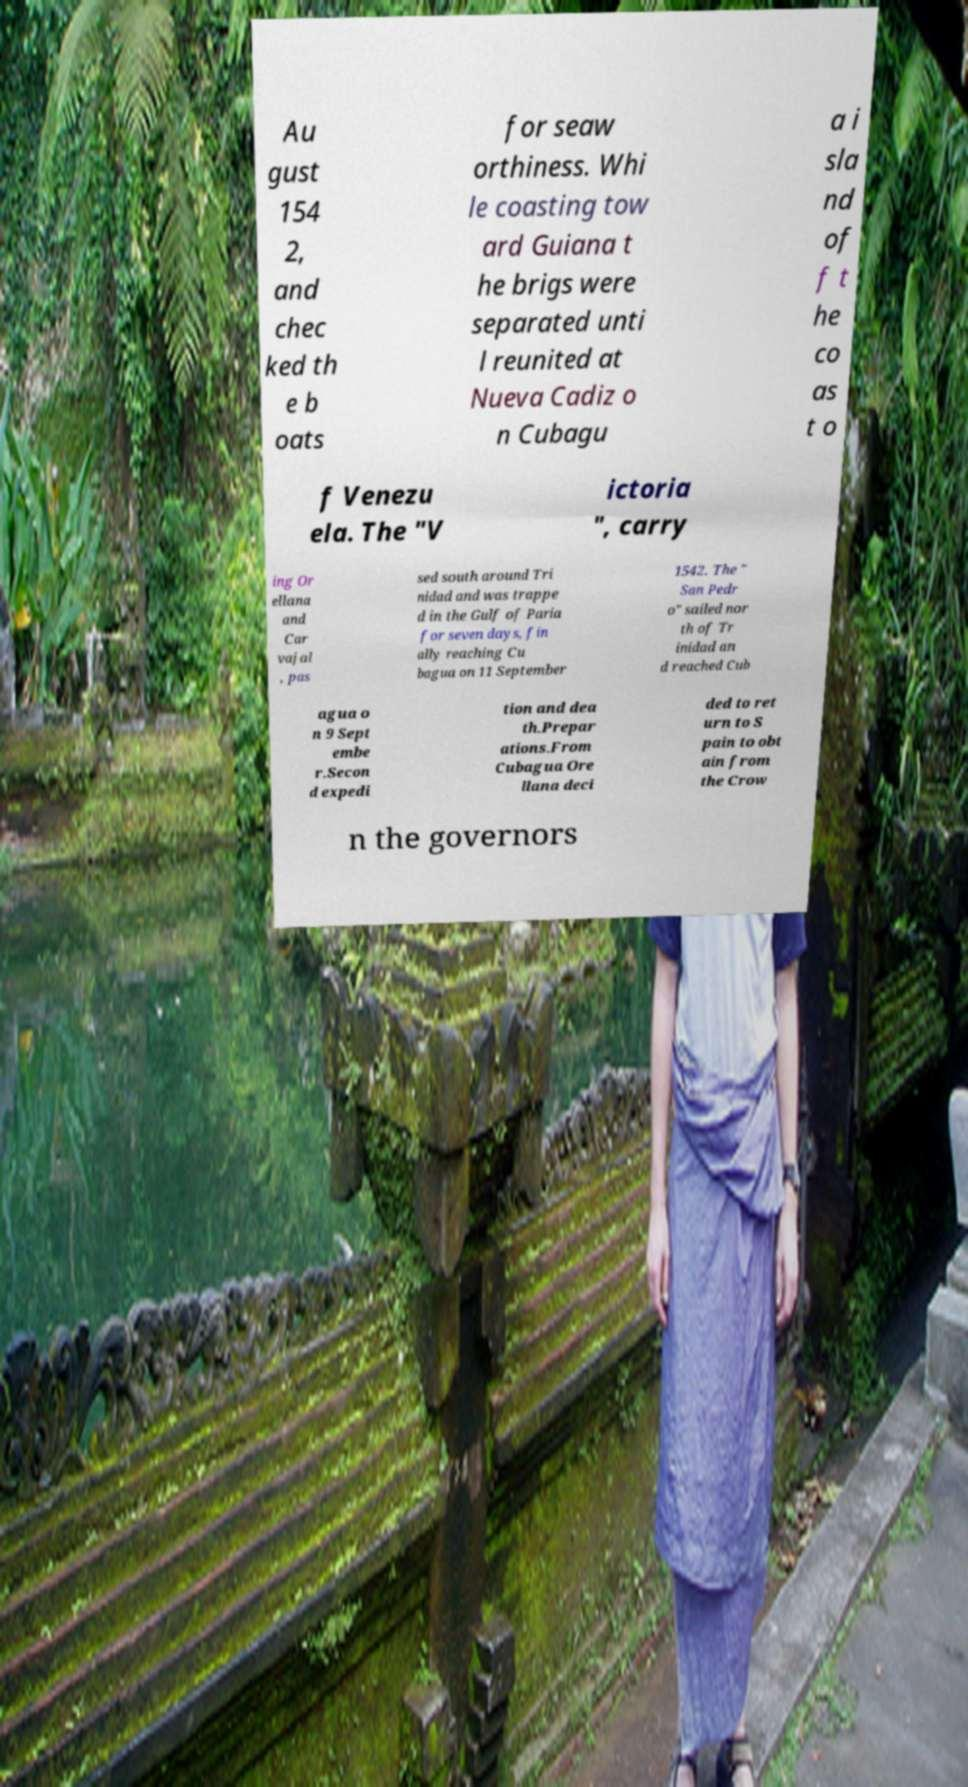Could you assist in decoding the text presented in this image and type it out clearly? Au gust 154 2, and chec ked th e b oats for seaw orthiness. Whi le coasting tow ard Guiana t he brigs were separated unti l reunited at Nueva Cadiz o n Cubagu a i sla nd of f t he co as t o f Venezu ela. The "V ictoria ", carry ing Or ellana and Car vajal , pas sed south around Tri nidad and was trappe d in the Gulf of Paria for seven days, fin ally reaching Cu bagua on 11 September 1542. The " San Pedr o" sailed nor th of Tr inidad an d reached Cub agua o n 9 Sept embe r.Secon d expedi tion and dea th.Prepar ations.From Cubagua Ore llana deci ded to ret urn to S pain to obt ain from the Crow n the governors 